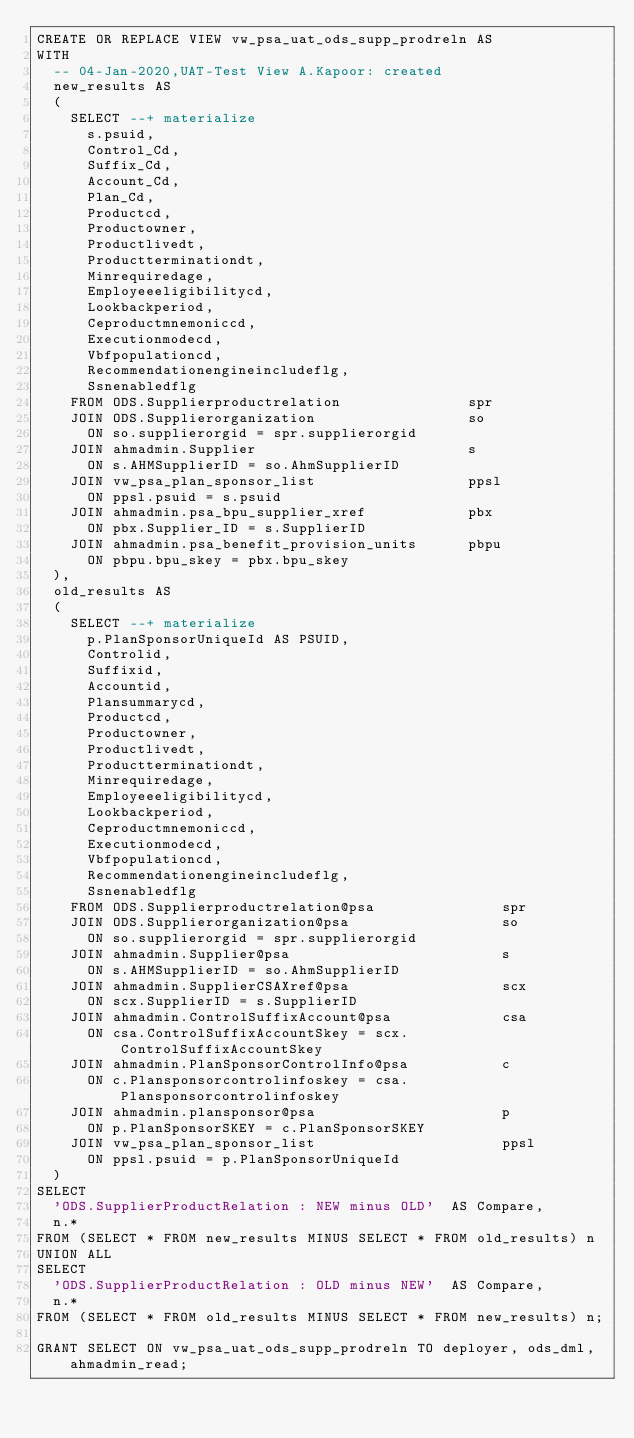<code> <loc_0><loc_0><loc_500><loc_500><_SQL_>CREATE OR REPLACE VIEW vw_psa_uat_ods_supp_prodreln AS
WITH
  -- 04-Jan-2020,UAT-Test View A.Kapoor: created
  new_results AS
  (
    SELECT --+ materialize
      s.psuid,
      Control_Cd,
      Suffix_Cd,
      Account_Cd,
      Plan_Cd,
      Productcd, 
      Productowner, 
      Productlivedt, 
      Productterminationdt, 
      Minrequiredage, 
      Employeeeligibilitycd, 
      Lookbackperiod, 
      Ceproductmnemoniccd, 
      Executionmodecd, 
      Vbfpopulationcd, 
      Recommendationengineincludeflg, 
      Ssnenabledflg 
    FROM ODS.Supplierproductrelation               spr
    JOIN ODS.Supplierorganization                  so
      ON so.supplierorgid = spr.supplierorgid
    JOIN ahmadmin.Supplier                         s
      ON s.AHMSupplierID = so.AhmSupplierID
    JOIN vw_psa_plan_sponsor_list                  ppsl
      ON ppsl.psuid = s.psuid
    JOIN ahmadmin.psa_bpu_supplier_xref            pbx
      ON pbx.Supplier_ID = s.SupplierID
    JOIN ahmadmin.psa_benefit_provision_units      pbpu
      ON pbpu.bpu_skey = pbx.bpu_skey  
  ),      
  old_results AS
  (
    SELECT --+ materialize
      p.PlanSponsorUniqueId AS PSUID,
      Controlid,
      Suffixid,
      Accountid,
      Plansummarycd,
      Productcd, 
      Productowner, 
      Productlivedt, 
      Productterminationdt, 
      Minrequiredage, 
      Employeeeligibilitycd, 
      Lookbackperiod, 
      Ceproductmnemoniccd, 
      Executionmodecd, 
      Vbfpopulationcd, 
      Recommendationengineincludeflg, 
      Ssnenabledflg 
    FROM ODS.Supplierproductrelation@psa               spr
    JOIN ODS.Supplierorganization@psa                  so
      ON so.supplierorgid = spr.supplierorgid
    JOIN ahmadmin.Supplier@psa                         s
      ON s.AHMSupplierID = so.AhmSupplierID
    JOIN ahmadmin.SupplierCSAXref@psa                  scx  
      ON scx.SupplierID = s.SupplierID
    JOIN ahmadmin.ControlSuffixAccount@psa             csa 
      ON csa.ControlSuffixAccountSkey = scx.ControlSuffixAccountSkey   
    JOIN ahmadmin.PlanSponsorControlInfo@psa           c 
      ON c.Plansponsorcontrolinfoskey = csa.Plansponsorcontrolinfoskey  
    JOIN ahmadmin.plansponsor@psa                      p 
      ON p.PlanSponsorSKEY = c.PlanSponsorSKEY 
    JOIN vw_psa_plan_sponsor_list                      ppsl
      ON ppsl.psuid = p.PlanSponsorUniqueId
  )
SELECT
  'ODS.SupplierProductRelation : NEW minus OLD'  AS Compare,
  n.* 
FROM (SELECT * FROM new_results MINUS SELECT * FROM old_results) n
UNION ALL
SELECT
  'ODS.SupplierProductRelation : OLD minus NEW'  AS Compare,
  n.* 
FROM (SELECT * FROM old_results MINUS SELECT * FROM new_results) n;

GRANT SELECT ON vw_psa_uat_ods_supp_prodreln TO deployer, ods_dml, ahmadmin_read;
</code> 